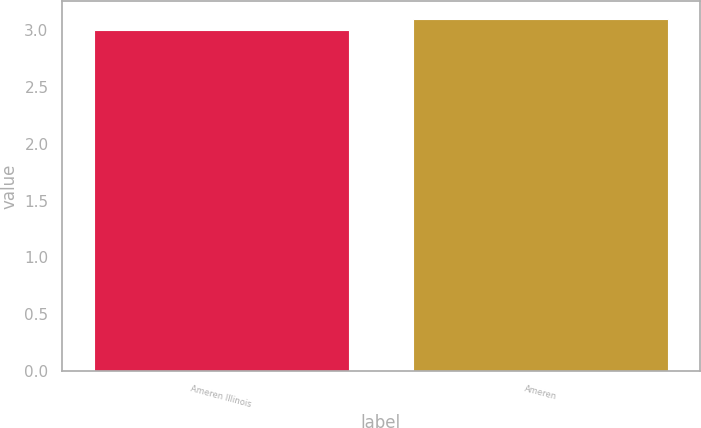Convert chart. <chart><loc_0><loc_0><loc_500><loc_500><bar_chart><fcel>Ameren Illinois<fcel>Ameren<nl><fcel>3<fcel>3.1<nl></chart> 